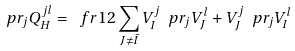Convert formula to latex. <formula><loc_0><loc_0><loc_500><loc_500>\ p r _ { j } Q _ { H } ^ { j l } = \ f r { 1 } { 2 } \sum _ { J \neq \bar { I } } V _ { I } ^ { j } \ p r _ { j } V _ { J } ^ { l } + V _ { J } ^ { j } \ p r _ { j } V _ { I } ^ { l }</formula> 